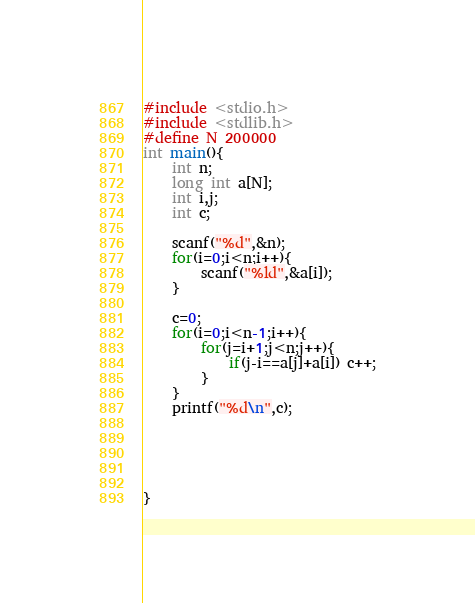<code> <loc_0><loc_0><loc_500><loc_500><_C_>#include <stdio.h>
#include <stdlib.h>
#define N 200000
int main(){
    int n;
    long int a[N];
    int i,j;
    int c;

    scanf("%d",&n);
    for(i=0;i<n;i++){
        scanf("%ld",&a[i]);
    }

    c=0;
    for(i=0;i<n-1;i++){
        for(j=i+1;j<n;j++){
            if(j-i==a[j]+a[i]) c++;
        }
    }
    printf("%d\n",c);





}</code> 